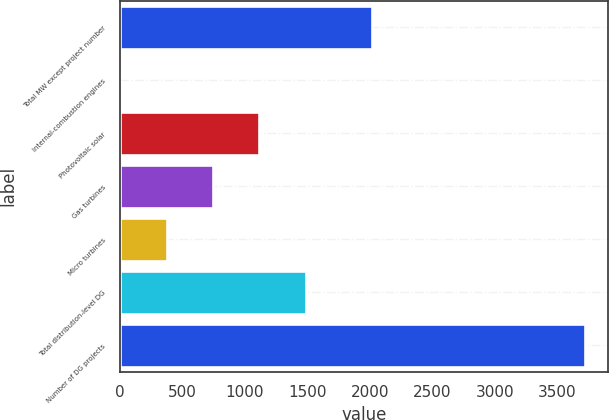<chart> <loc_0><loc_0><loc_500><loc_500><bar_chart><fcel>Total MW except project number<fcel>Internal-combustion engines<fcel>Photovoltaic solar<fcel>Gas turbines<fcel>Micro turbines<fcel>Total distribution-level DG<fcel>Number of DG projects<nl><fcel>2015<fcel>1<fcel>1116.1<fcel>744.4<fcel>372.7<fcel>1487.8<fcel>3718<nl></chart> 